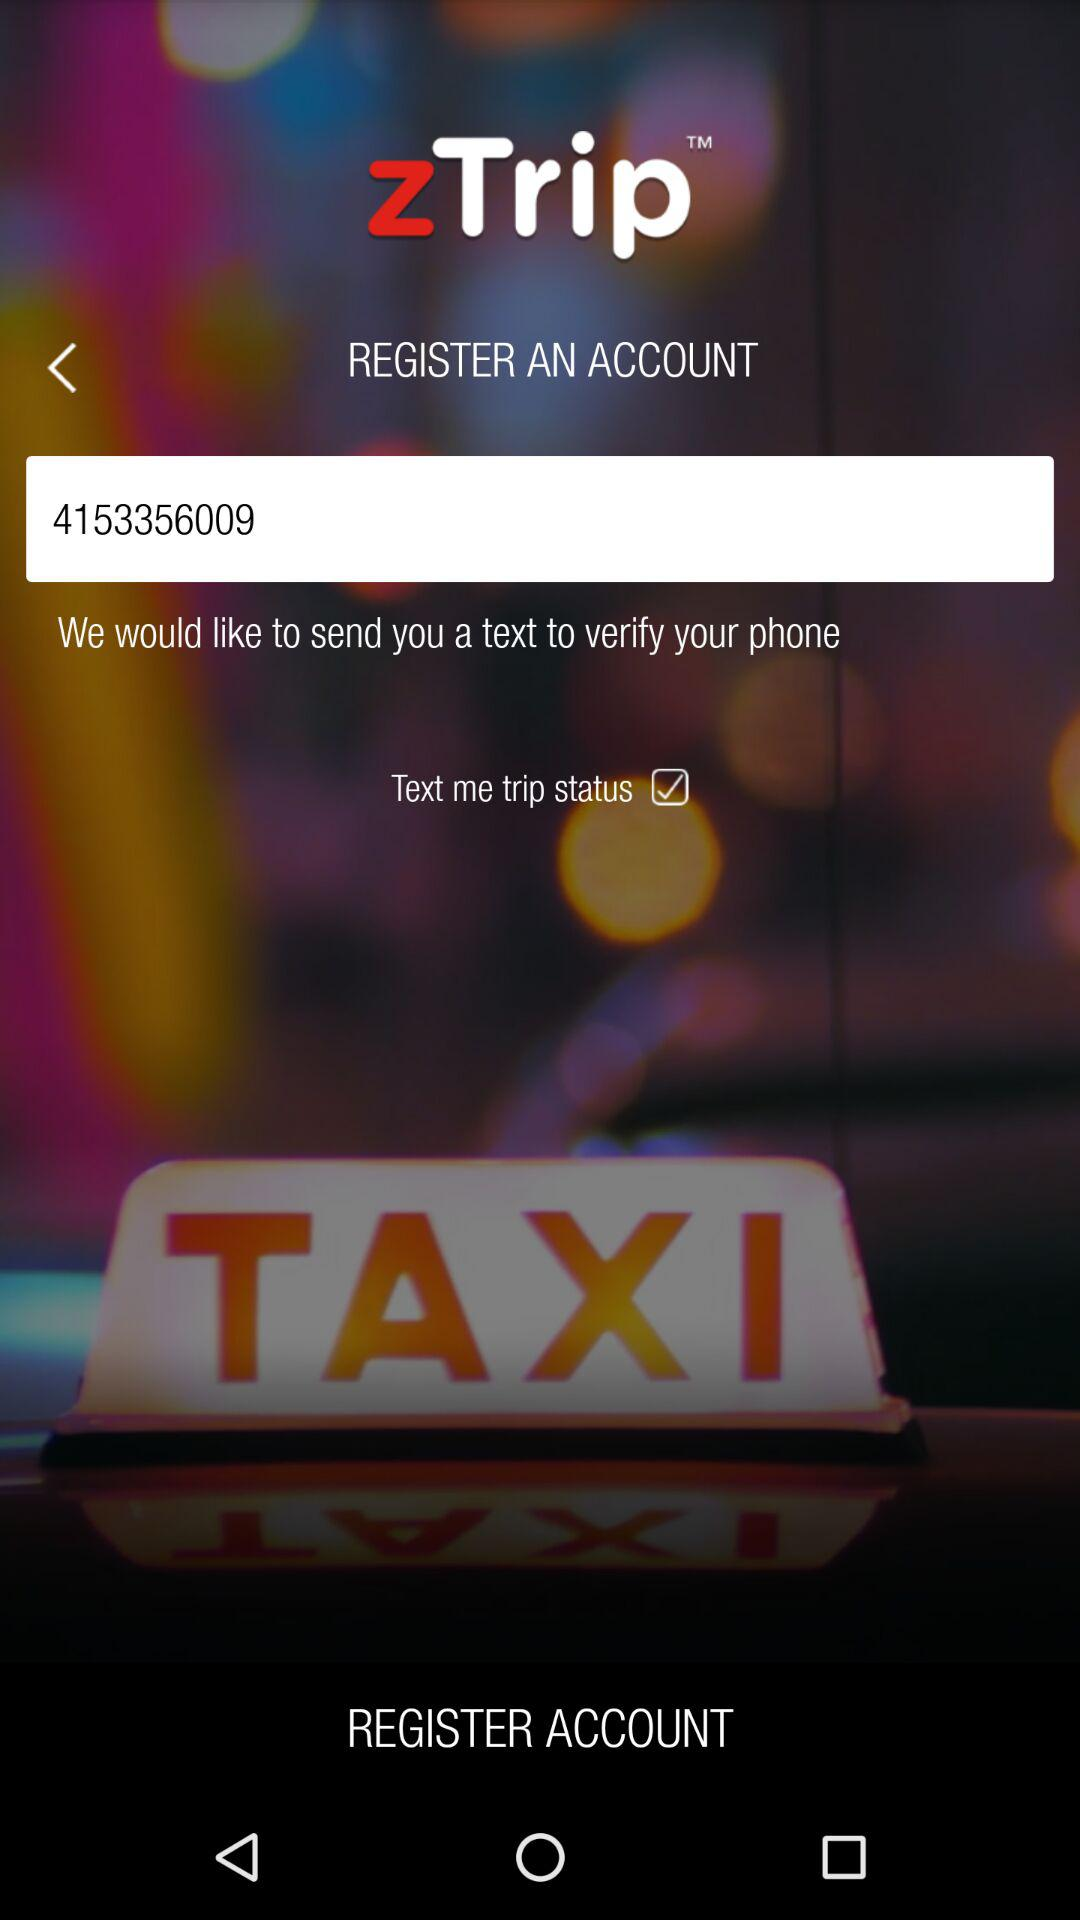How many text input fields are there on this screen?
Answer the question using a single word or phrase. 1 